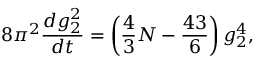Convert formula to latex. <formula><loc_0><loc_0><loc_500><loc_500>8 \pi ^ { 2 } { \frac { d g _ { 2 } ^ { 2 } } { d t } } = \left ( { \frac { 4 } { 3 } } N - { \frac { 4 3 } { 6 } } \right ) g _ { 2 } ^ { 4 } ,</formula> 